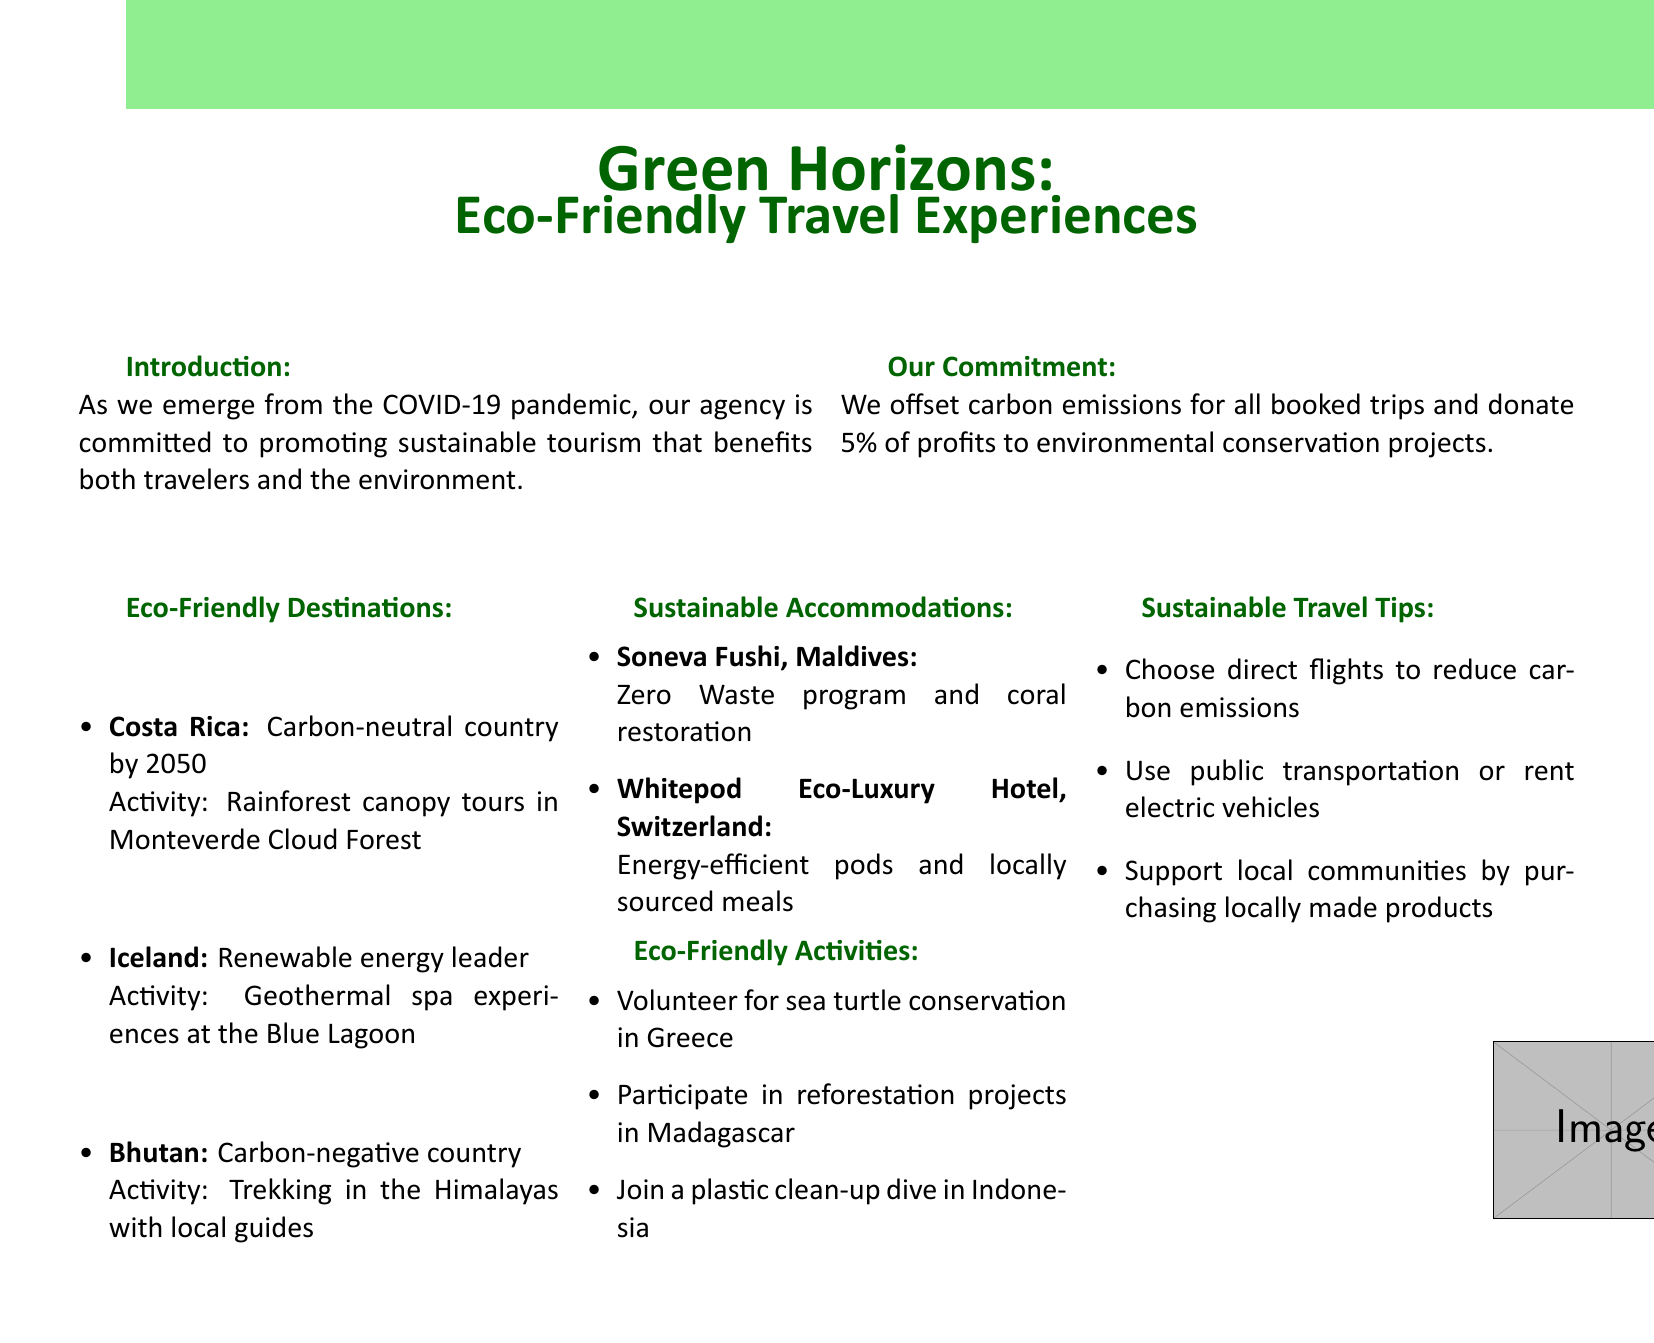What is the name of the catalog? The catalog's title is presented prominently at the top of the document as "Green Horizons: Eco-Friendly Travel Experiences."
Answer: Green Horizons: Eco-Friendly Travel Experiences Which country is carbon-negative? The document specifies Bhutan as a carbon-negative country, highlighting its environmental efforts.
Answer: Bhutan What percentage of profits does the agency donate? The agency's commitment includes donating a specific percentage of profits to conservation, which is stated clearly in the document.
Answer: 5% What type of accommodation is Soneva Fushi known for? The document describes Soneva Fushi as a Zero Waste program and coral restoration accommodation option.
Answer: Zero Waste program What activity can you volunteer for in Greece? The document lists a specific volunteer opportunity involving endangered species, indicating what travelers can participate in while in Greece.
Answer: Sea turtle conservation How many eco-friendly destinations are listed? By counting the destinations mentioned in the document's eco-friendly section, one can determine the total number of destinations featured.
Answer: 3 What is one sustainable travel tip provided? The document offers practical suggestions for sustainable travel, and one example is easily retrievable from the tips section.
Answer: Choose direct flights What is a unique feature of the Whitepod Eco-Luxury Hotel? The document details distinctive attributes of the Whitepod Eco-Luxury Hotel, particularly focusing on their energy efficiency and cuisine sourcing.
Answer: Energy-efficient pods 